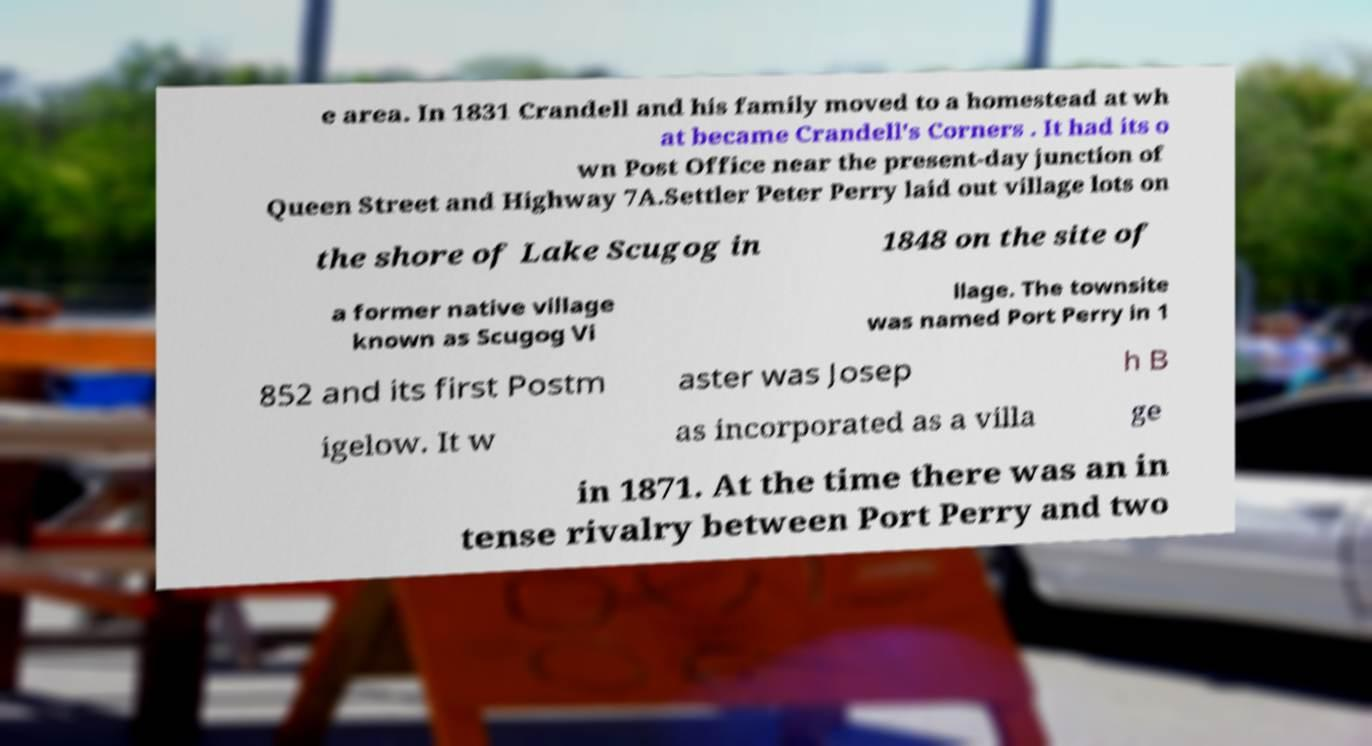Can you read and provide the text displayed in the image?This photo seems to have some interesting text. Can you extract and type it out for me? e area. In 1831 Crandell and his family moved to a homestead at wh at became Crandell's Corners . It had its o wn Post Office near the present-day junction of Queen Street and Highway 7A.Settler Peter Perry laid out village lots on the shore of Lake Scugog in 1848 on the site of a former native village known as Scugog Vi llage. The townsite was named Port Perry in 1 852 and its first Postm aster was Josep h B igelow. It w as incorporated as a villa ge in 1871. At the time there was an in tense rivalry between Port Perry and two 